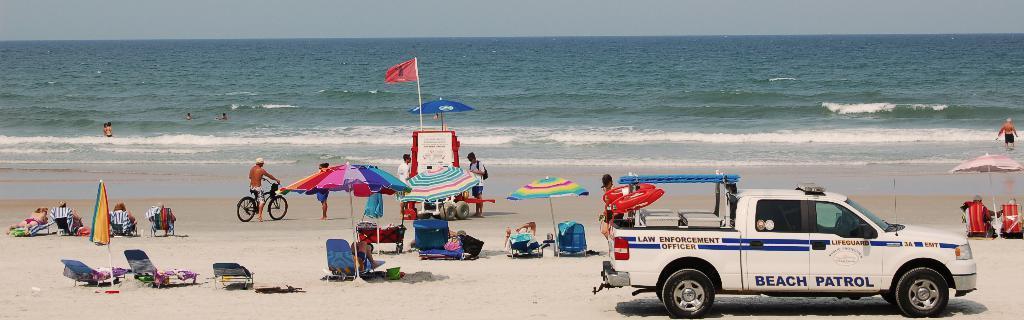In one or two sentences, can you explain what this image depicts? In this image, we can see a vehicle. We can see the ground with some objects. There are a few people, chairs, umbrellas, poles. We can see some water and red colored objects. We can see the sky. 